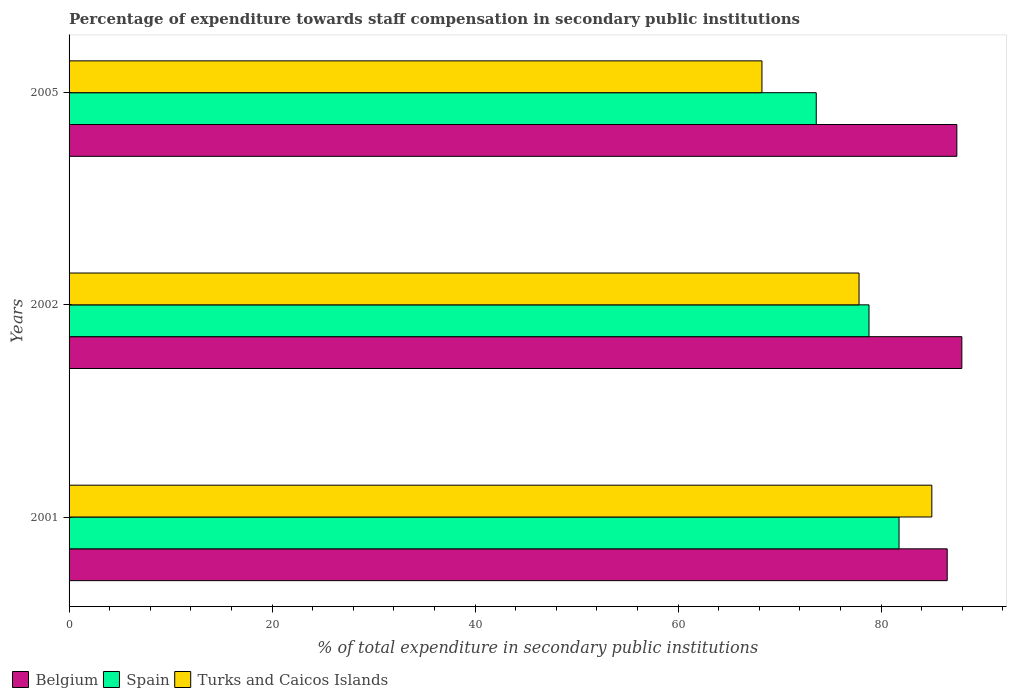Are the number of bars on each tick of the Y-axis equal?
Keep it short and to the point. Yes. What is the label of the 1st group of bars from the top?
Give a very brief answer. 2005. What is the percentage of expenditure towards staff compensation in Spain in 2001?
Offer a terse response. 81.78. Across all years, what is the maximum percentage of expenditure towards staff compensation in Turks and Caicos Islands?
Ensure brevity in your answer.  85.01. Across all years, what is the minimum percentage of expenditure towards staff compensation in Turks and Caicos Islands?
Ensure brevity in your answer.  68.27. In which year was the percentage of expenditure towards staff compensation in Turks and Caicos Islands maximum?
Provide a succinct answer. 2001. In which year was the percentage of expenditure towards staff compensation in Spain minimum?
Provide a succinct answer. 2005. What is the total percentage of expenditure towards staff compensation in Spain in the graph?
Make the answer very short. 234.22. What is the difference between the percentage of expenditure towards staff compensation in Belgium in 2001 and that in 2005?
Keep it short and to the point. -0.95. What is the difference between the percentage of expenditure towards staff compensation in Turks and Caicos Islands in 2005 and the percentage of expenditure towards staff compensation in Spain in 2001?
Provide a short and direct response. -13.51. What is the average percentage of expenditure towards staff compensation in Spain per year?
Provide a short and direct response. 78.07. In the year 2002, what is the difference between the percentage of expenditure towards staff compensation in Spain and percentage of expenditure towards staff compensation in Belgium?
Keep it short and to the point. -9.15. What is the ratio of the percentage of expenditure towards staff compensation in Belgium in 2002 to that in 2005?
Your answer should be compact. 1.01. Is the percentage of expenditure towards staff compensation in Spain in 2001 less than that in 2005?
Your answer should be compact. No. Is the difference between the percentage of expenditure towards staff compensation in Spain in 2001 and 2005 greater than the difference between the percentage of expenditure towards staff compensation in Belgium in 2001 and 2005?
Give a very brief answer. Yes. What is the difference between the highest and the second highest percentage of expenditure towards staff compensation in Belgium?
Offer a terse response. 0.49. What is the difference between the highest and the lowest percentage of expenditure towards staff compensation in Spain?
Offer a very short reply. 8.16. In how many years, is the percentage of expenditure towards staff compensation in Spain greater than the average percentage of expenditure towards staff compensation in Spain taken over all years?
Ensure brevity in your answer.  2. What does the 1st bar from the top in 2001 represents?
Your answer should be very brief. Turks and Caicos Islands. Is it the case that in every year, the sum of the percentage of expenditure towards staff compensation in Turks and Caicos Islands and percentage of expenditure towards staff compensation in Spain is greater than the percentage of expenditure towards staff compensation in Belgium?
Offer a terse response. Yes. Are all the bars in the graph horizontal?
Make the answer very short. Yes. Does the graph contain any zero values?
Make the answer very short. No. What is the title of the graph?
Your response must be concise. Percentage of expenditure towards staff compensation in secondary public institutions. Does "Zambia" appear as one of the legend labels in the graph?
Your answer should be compact. No. What is the label or title of the X-axis?
Offer a terse response. % of total expenditure in secondary public institutions. What is the label or title of the Y-axis?
Provide a succinct answer. Years. What is the % of total expenditure in secondary public institutions of Belgium in 2001?
Keep it short and to the point. 86.52. What is the % of total expenditure in secondary public institutions in Spain in 2001?
Your answer should be compact. 81.78. What is the % of total expenditure in secondary public institutions in Turks and Caicos Islands in 2001?
Keep it short and to the point. 85.01. What is the % of total expenditure in secondary public institutions of Belgium in 2002?
Provide a succinct answer. 87.97. What is the % of total expenditure in secondary public institutions of Spain in 2002?
Keep it short and to the point. 78.82. What is the % of total expenditure in secondary public institutions in Turks and Caicos Islands in 2002?
Give a very brief answer. 77.84. What is the % of total expenditure in secondary public institutions in Belgium in 2005?
Provide a short and direct response. 87.47. What is the % of total expenditure in secondary public institutions in Spain in 2005?
Keep it short and to the point. 73.62. What is the % of total expenditure in secondary public institutions of Turks and Caicos Islands in 2005?
Your answer should be compact. 68.27. Across all years, what is the maximum % of total expenditure in secondary public institutions of Belgium?
Give a very brief answer. 87.97. Across all years, what is the maximum % of total expenditure in secondary public institutions in Spain?
Your answer should be compact. 81.78. Across all years, what is the maximum % of total expenditure in secondary public institutions in Turks and Caicos Islands?
Provide a succinct answer. 85.01. Across all years, what is the minimum % of total expenditure in secondary public institutions of Belgium?
Offer a very short reply. 86.52. Across all years, what is the minimum % of total expenditure in secondary public institutions in Spain?
Offer a very short reply. 73.62. Across all years, what is the minimum % of total expenditure in secondary public institutions in Turks and Caicos Islands?
Your answer should be compact. 68.27. What is the total % of total expenditure in secondary public institutions of Belgium in the graph?
Offer a terse response. 261.96. What is the total % of total expenditure in secondary public institutions of Spain in the graph?
Your response must be concise. 234.22. What is the total % of total expenditure in secondary public institutions in Turks and Caicos Islands in the graph?
Keep it short and to the point. 231.12. What is the difference between the % of total expenditure in secondary public institutions of Belgium in 2001 and that in 2002?
Offer a terse response. -1.44. What is the difference between the % of total expenditure in secondary public institutions of Spain in 2001 and that in 2002?
Offer a very short reply. 2.96. What is the difference between the % of total expenditure in secondary public institutions of Turks and Caicos Islands in 2001 and that in 2002?
Ensure brevity in your answer.  7.17. What is the difference between the % of total expenditure in secondary public institutions of Belgium in 2001 and that in 2005?
Your answer should be very brief. -0.95. What is the difference between the % of total expenditure in secondary public institutions of Spain in 2001 and that in 2005?
Offer a terse response. 8.16. What is the difference between the % of total expenditure in secondary public institutions in Turks and Caicos Islands in 2001 and that in 2005?
Provide a short and direct response. 16.74. What is the difference between the % of total expenditure in secondary public institutions in Belgium in 2002 and that in 2005?
Your answer should be very brief. 0.49. What is the difference between the % of total expenditure in secondary public institutions of Spain in 2002 and that in 2005?
Offer a terse response. 5.2. What is the difference between the % of total expenditure in secondary public institutions in Turks and Caicos Islands in 2002 and that in 2005?
Give a very brief answer. 9.57. What is the difference between the % of total expenditure in secondary public institutions in Belgium in 2001 and the % of total expenditure in secondary public institutions in Spain in 2002?
Your answer should be compact. 7.71. What is the difference between the % of total expenditure in secondary public institutions of Belgium in 2001 and the % of total expenditure in secondary public institutions of Turks and Caicos Islands in 2002?
Keep it short and to the point. 8.69. What is the difference between the % of total expenditure in secondary public institutions in Spain in 2001 and the % of total expenditure in secondary public institutions in Turks and Caicos Islands in 2002?
Provide a succinct answer. 3.94. What is the difference between the % of total expenditure in secondary public institutions in Belgium in 2001 and the % of total expenditure in secondary public institutions in Spain in 2005?
Provide a succinct answer. 12.9. What is the difference between the % of total expenditure in secondary public institutions of Belgium in 2001 and the % of total expenditure in secondary public institutions of Turks and Caicos Islands in 2005?
Offer a terse response. 18.25. What is the difference between the % of total expenditure in secondary public institutions in Spain in 2001 and the % of total expenditure in secondary public institutions in Turks and Caicos Islands in 2005?
Ensure brevity in your answer.  13.51. What is the difference between the % of total expenditure in secondary public institutions of Belgium in 2002 and the % of total expenditure in secondary public institutions of Spain in 2005?
Provide a short and direct response. 14.35. What is the difference between the % of total expenditure in secondary public institutions of Belgium in 2002 and the % of total expenditure in secondary public institutions of Turks and Caicos Islands in 2005?
Your response must be concise. 19.7. What is the difference between the % of total expenditure in secondary public institutions of Spain in 2002 and the % of total expenditure in secondary public institutions of Turks and Caicos Islands in 2005?
Ensure brevity in your answer.  10.55. What is the average % of total expenditure in secondary public institutions in Belgium per year?
Ensure brevity in your answer.  87.32. What is the average % of total expenditure in secondary public institutions in Spain per year?
Give a very brief answer. 78.07. What is the average % of total expenditure in secondary public institutions in Turks and Caicos Islands per year?
Provide a short and direct response. 77.04. In the year 2001, what is the difference between the % of total expenditure in secondary public institutions of Belgium and % of total expenditure in secondary public institutions of Spain?
Provide a succinct answer. 4.75. In the year 2001, what is the difference between the % of total expenditure in secondary public institutions of Belgium and % of total expenditure in secondary public institutions of Turks and Caicos Islands?
Keep it short and to the point. 1.52. In the year 2001, what is the difference between the % of total expenditure in secondary public institutions in Spain and % of total expenditure in secondary public institutions in Turks and Caicos Islands?
Your answer should be compact. -3.23. In the year 2002, what is the difference between the % of total expenditure in secondary public institutions in Belgium and % of total expenditure in secondary public institutions in Spain?
Offer a very short reply. 9.15. In the year 2002, what is the difference between the % of total expenditure in secondary public institutions in Belgium and % of total expenditure in secondary public institutions in Turks and Caicos Islands?
Your answer should be very brief. 10.13. In the year 2002, what is the difference between the % of total expenditure in secondary public institutions of Spain and % of total expenditure in secondary public institutions of Turks and Caicos Islands?
Give a very brief answer. 0.98. In the year 2005, what is the difference between the % of total expenditure in secondary public institutions in Belgium and % of total expenditure in secondary public institutions in Spain?
Your answer should be compact. 13.85. In the year 2005, what is the difference between the % of total expenditure in secondary public institutions in Belgium and % of total expenditure in secondary public institutions in Turks and Caicos Islands?
Your response must be concise. 19.2. In the year 2005, what is the difference between the % of total expenditure in secondary public institutions in Spain and % of total expenditure in secondary public institutions in Turks and Caicos Islands?
Provide a short and direct response. 5.35. What is the ratio of the % of total expenditure in secondary public institutions in Belgium in 2001 to that in 2002?
Ensure brevity in your answer.  0.98. What is the ratio of the % of total expenditure in secondary public institutions of Spain in 2001 to that in 2002?
Provide a succinct answer. 1.04. What is the ratio of the % of total expenditure in secondary public institutions in Turks and Caicos Islands in 2001 to that in 2002?
Offer a very short reply. 1.09. What is the ratio of the % of total expenditure in secondary public institutions of Spain in 2001 to that in 2005?
Offer a terse response. 1.11. What is the ratio of the % of total expenditure in secondary public institutions in Turks and Caicos Islands in 2001 to that in 2005?
Your response must be concise. 1.25. What is the ratio of the % of total expenditure in secondary public institutions in Belgium in 2002 to that in 2005?
Your response must be concise. 1.01. What is the ratio of the % of total expenditure in secondary public institutions in Spain in 2002 to that in 2005?
Ensure brevity in your answer.  1.07. What is the ratio of the % of total expenditure in secondary public institutions in Turks and Caicos Islands in 2002 to that in 2005?
Give a very brief answer. 1.14. What is the difference between the highest and the second highest % of total expenditure in secondary public institutions in Belgium?
Your answer should be compact. 0.49. What is the difference between the highest and the second highest % of total expenditure in secondary public institutions in Spain?
Offer a very short reply. 2.96. What is the difference between the highest and the second highest % of total expenditure in secondary public institutions in Turks and Caicos Islands?
Provide a short and direct response. 7.17. What is the difference between the highest and the lowest % of total expenditure in secondary public institutions of Belgium?
Ensure brevity in your answer.  1.44. What is the difference between the highest and the lowest % of total expenditure in secondary public institutions in Spain?
Give a very brief answer. 8.16. What is the difference between the highest and the lowest % of total expenditure in secondary public institutions in Turks and Caicos Islands?
Your response must be concise. 16.74. 